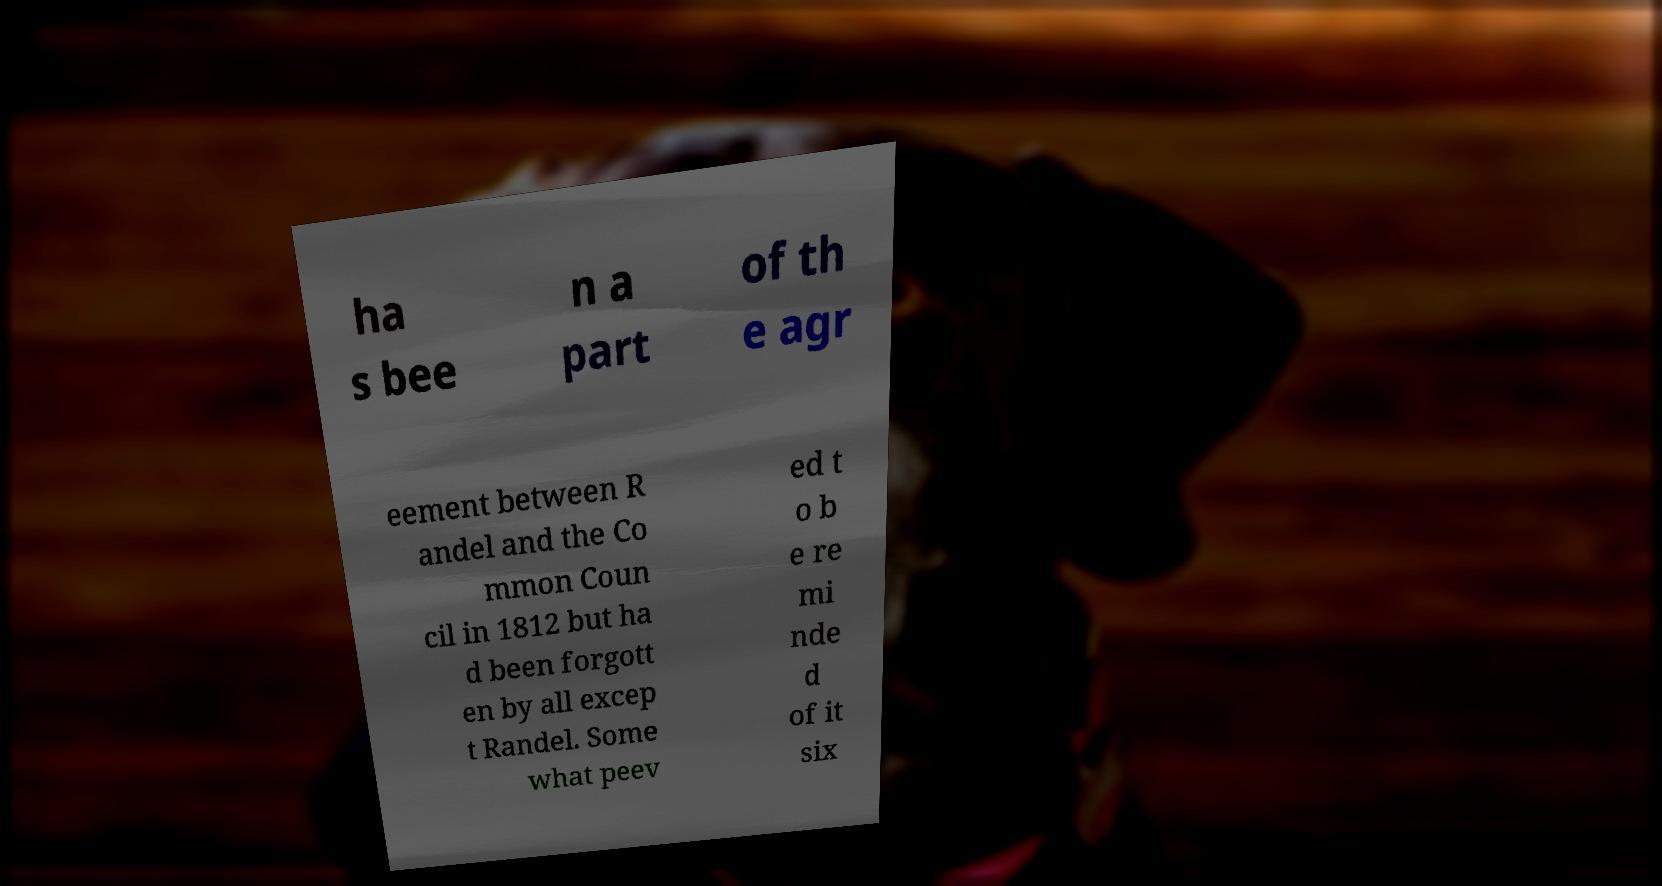What messages or text are displayed in this image? I need them in a readable, typed format. ha s bee n a part of th e agr eement between R andel and the Co mmon Coun cil in 1812 but ha d been forgott en by all excep t Randel. Some what peev ed t o b e re mi nde d of it six 